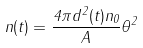<formula> <loc_0><loc_0><loc_500><loc_500>n ( t ) = \frac { 4 \pi d ^ { 2 } ( t ) n _ { 0 } } { A } \theta ^ { 2 }</formula> 